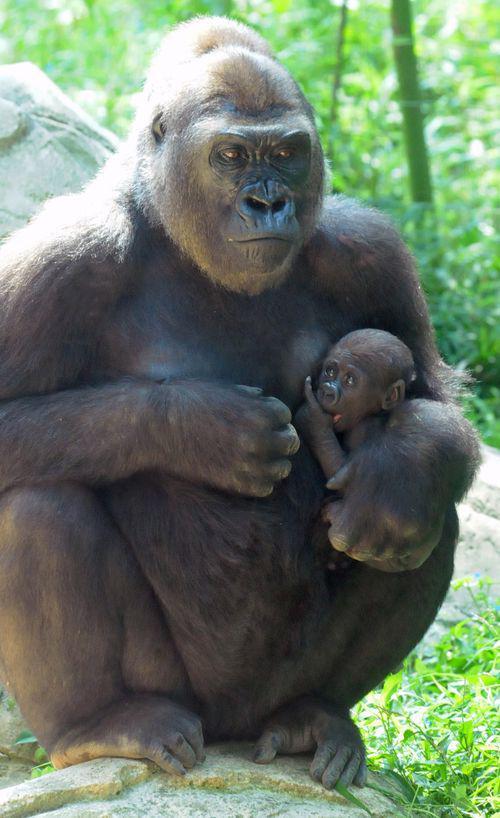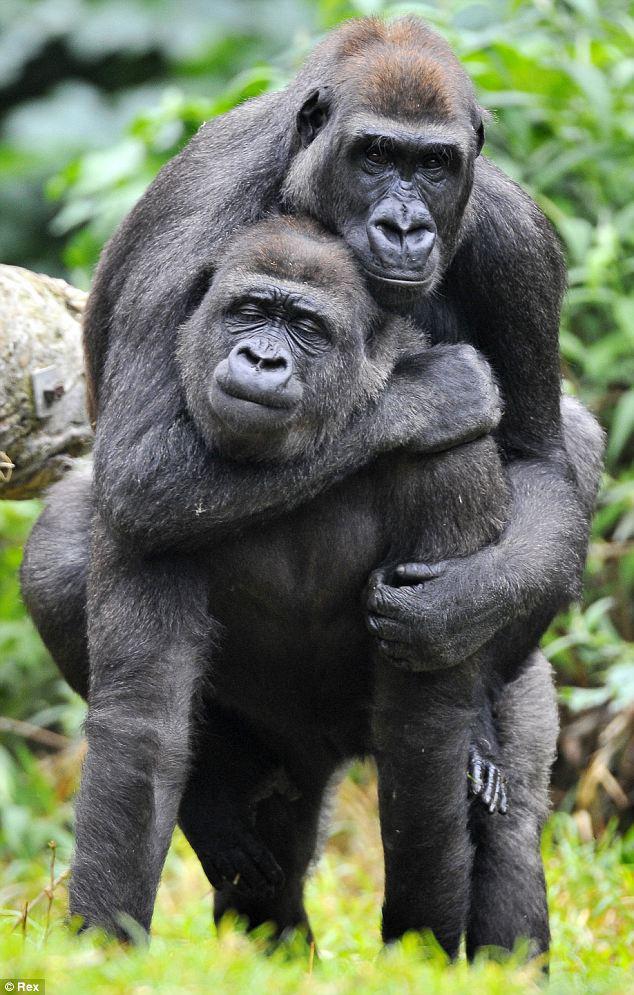The first image is the image on the left, the second image is the image on the right. Assess this claim about the two images: "There is one small, baby gorilla being carried by its mother.". Correct or not? Answer yes or no. Yes. The first image is the image on the left, the second image is the image on the right. For the images shown, is this caption "Left image shows a baby gorilla positioned in front of a sitting adult." true? Answer yes or no. Yes. 